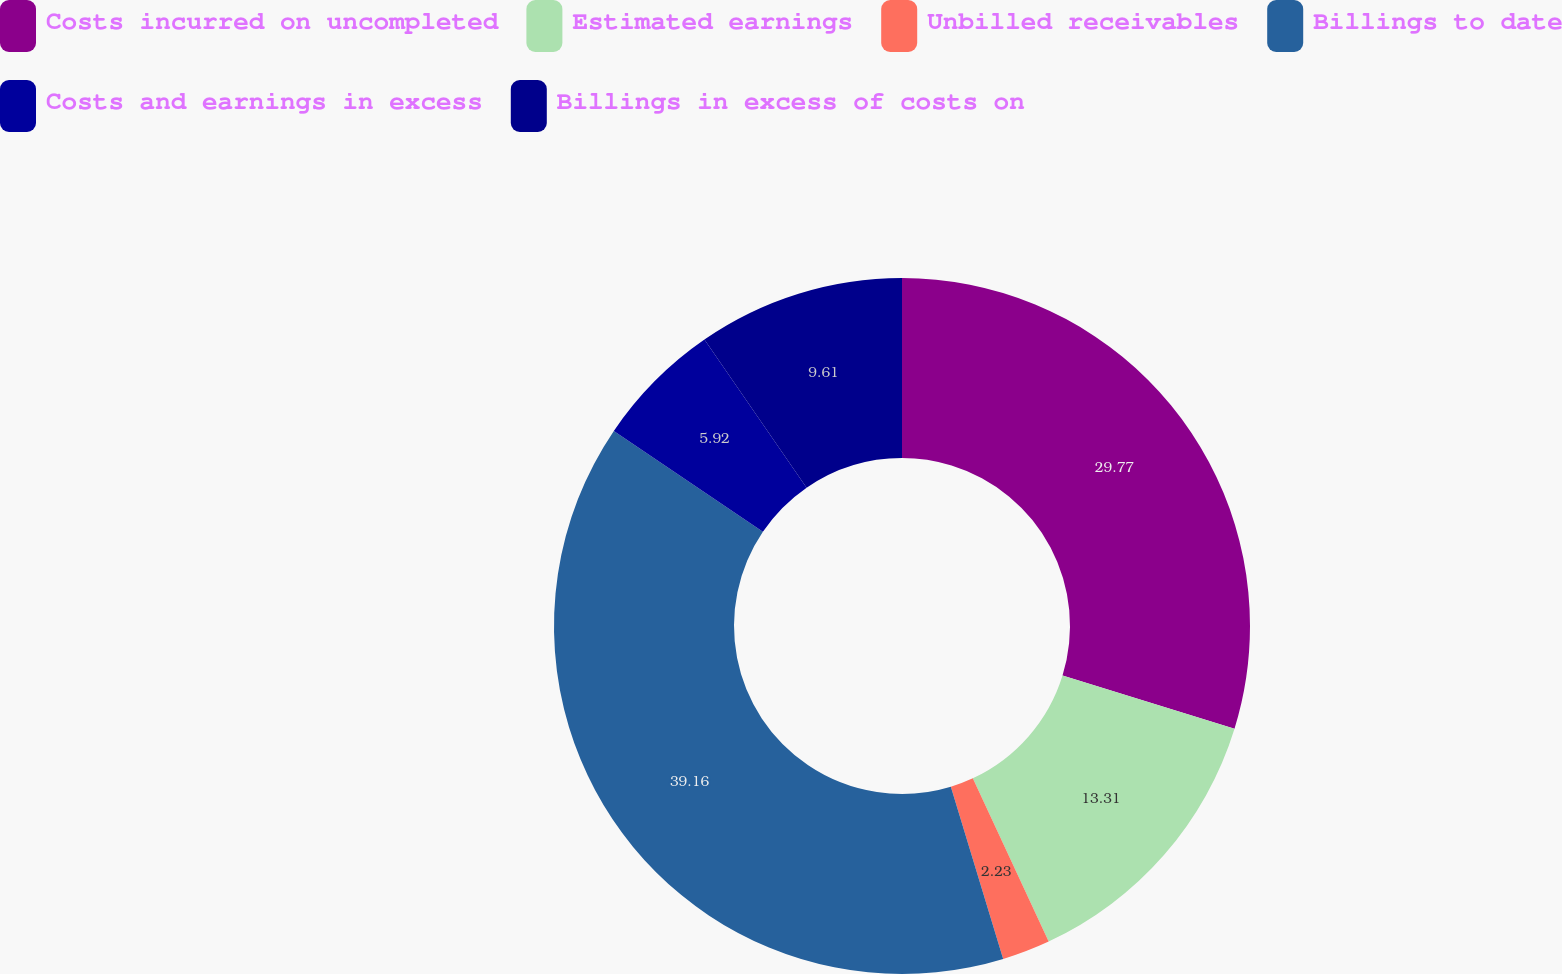Convert chart to OTSL. <chart><loc_0><loc_0><loc_500><loc_500><pie_chart><fcel>Costs incurred on uncompleted<fcel>Estimated earnings<fcel>Unbilled receivables<fcel>Billings to date<fcel>Costs and earnings in excess<fcel>Billings in excess of costs on<nl><fcel>29.77%<fcel>13.31%<fcel>2.23%<fcel>39.17%<fcel>5.92%<fcel>9.61%<nl></chart> 